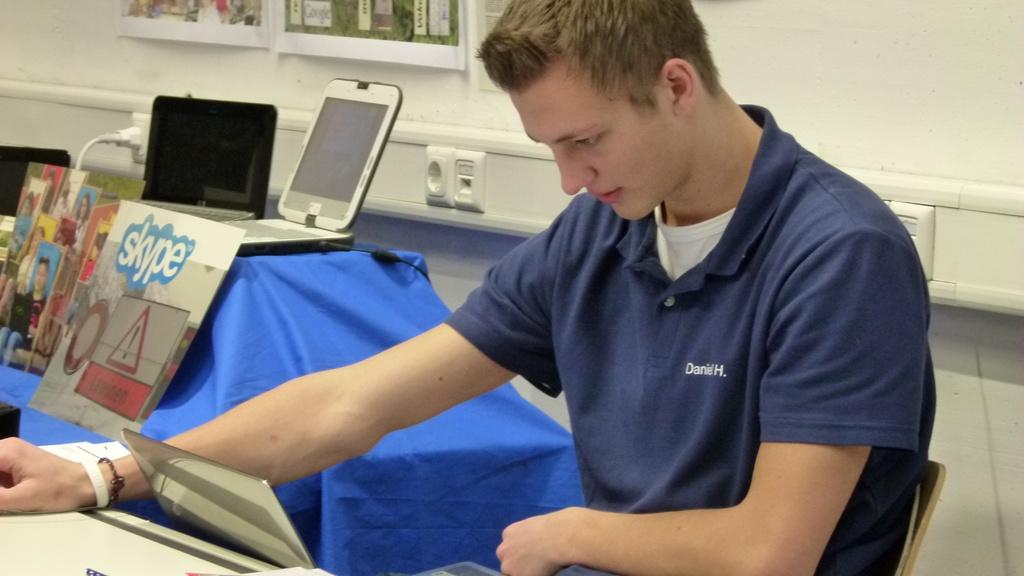<image>
Relay a brief, clear account of the picture shown. A man with Daniel H. stitched into his shirt. 